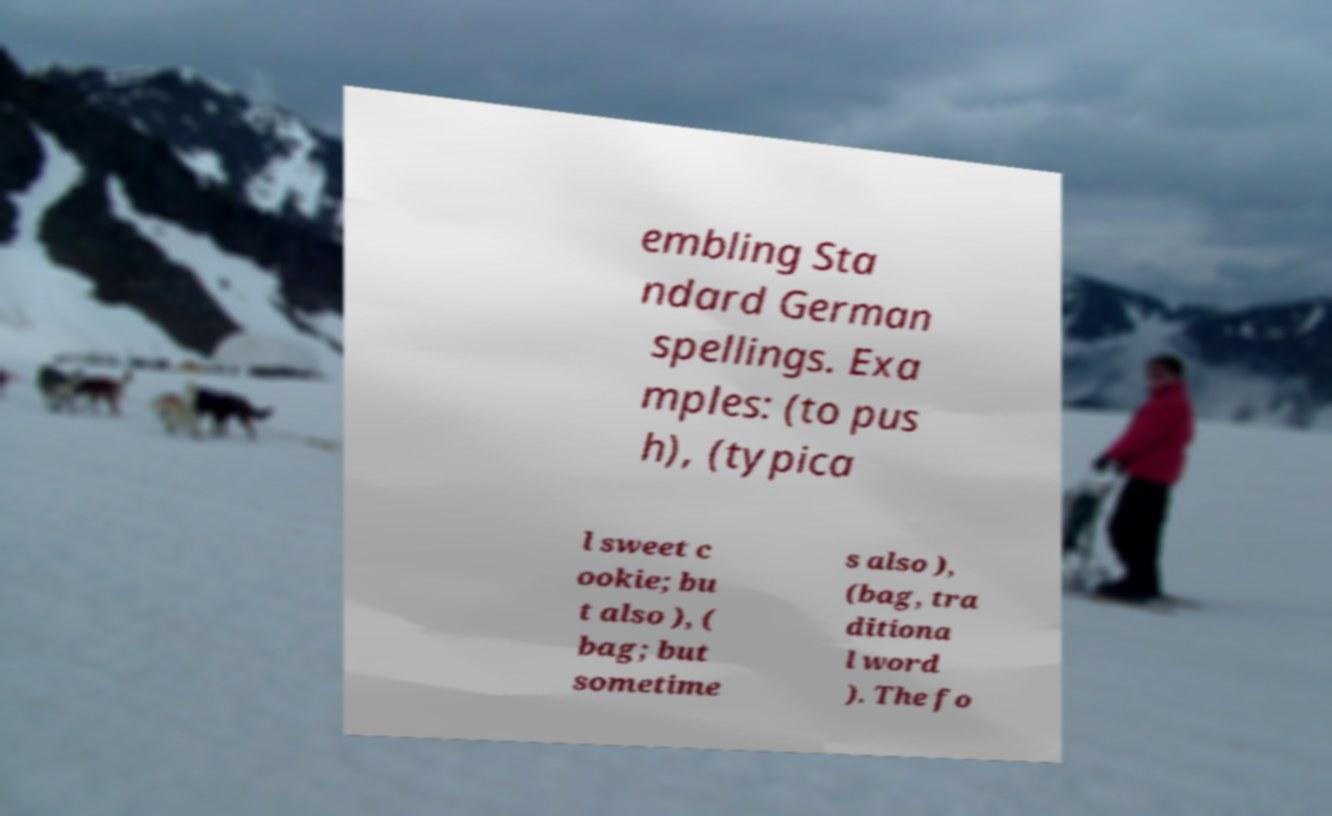For documentation purposes, I need the text within this image transcribed. Could you provide that? embling Sta ndard German spellings. Exa mples: (to pus h), (typica l sweet c ookie; bu t also ), ( bag; but sometime s also ), (bag, tra ditiona l word ). The fo 